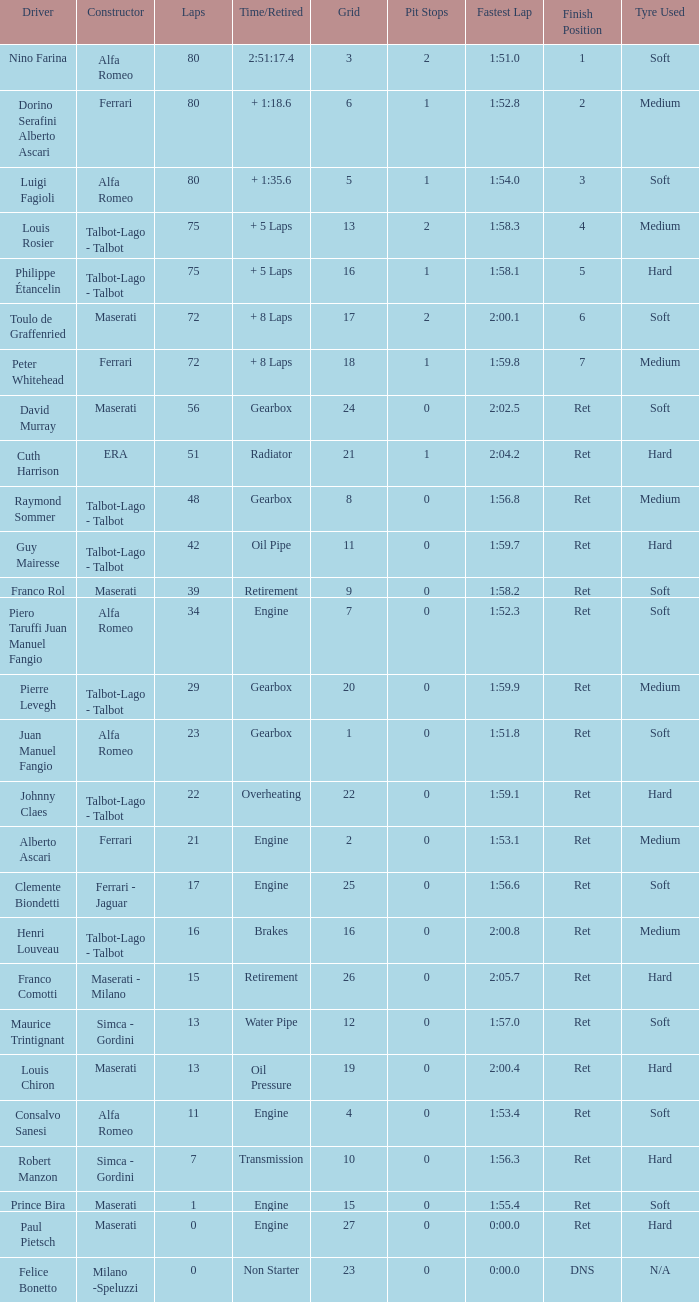What was the smallest grid for Prince bira? 15.0. 